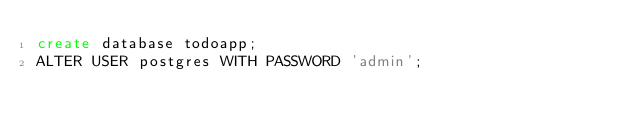<code> <loc_0><loc_0><loc_500><loc_500><_SQL_>create database todoapp;
ALTER USER postgres WITH PASSWORD 'admin';</code> 